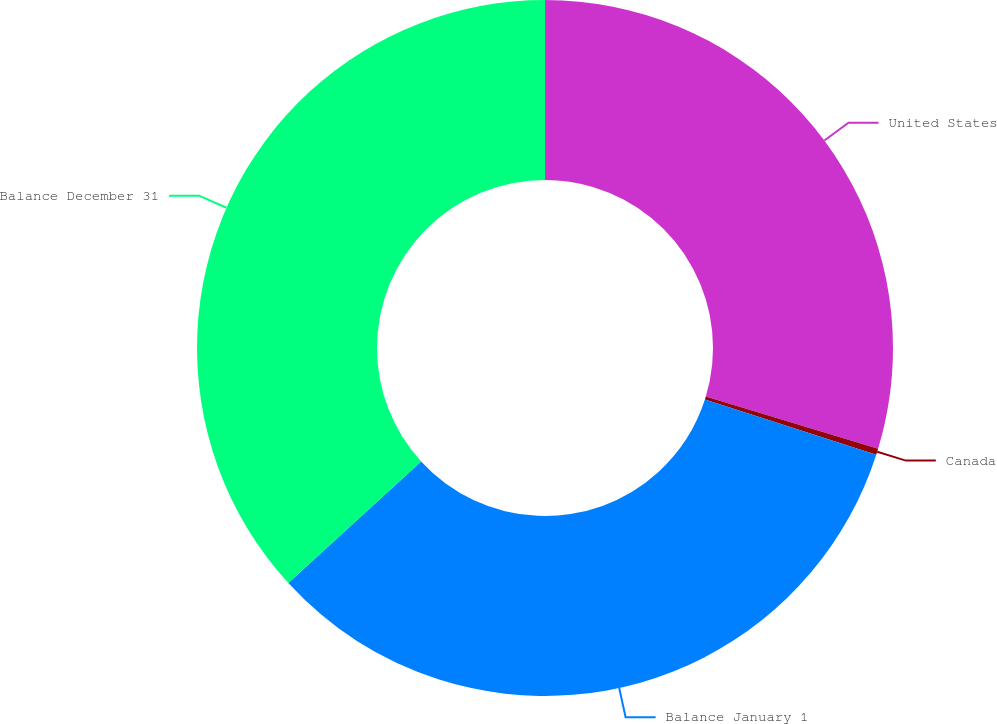<chart> <loc_0><loc_0><loc_500><loc_500><pie_chart><fcel>United States<fcel>Canada<fcel>Balance January 1<fcel>Balance December 31<nl><fcel>29.67%<fcel>0.29%<fcel>33.24%<fcel>36.8%<nl></chart> 